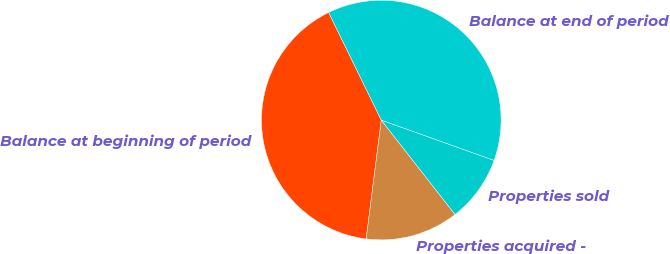Convert chart. <chart><loc_0><loc_0><loc_500><loc_500><pie_chart><fcel>Balance at beginning of period<fcel>Properties acquired -<fcel>Properties sold<fcel>Balance at end of period<nl><fcel>40.75%<fcel>12.57%<fcel>8.98%<fcel>37.7%<nl></chart> 